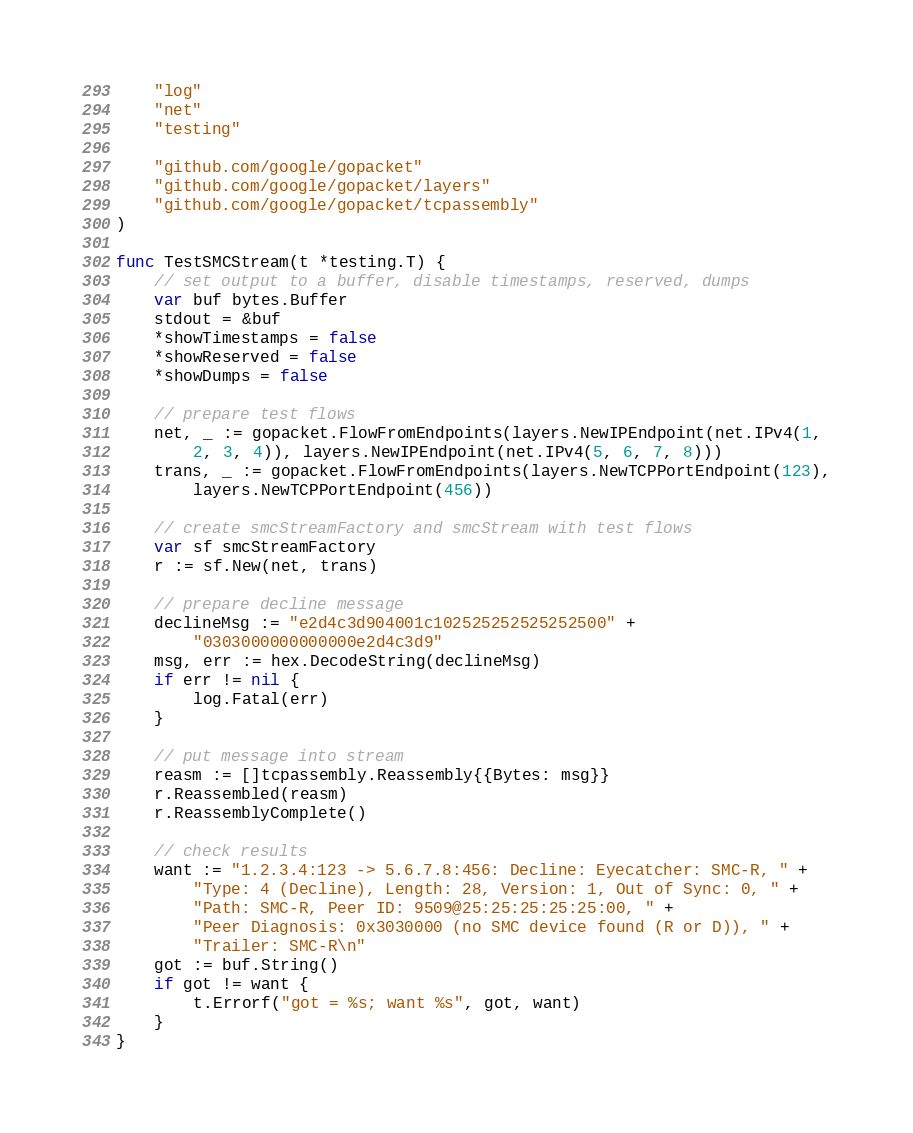<code> <loc_0><loc_0><loc_500><loc_500><_Go_>	"log"
	"net"
	"testing"

	"github.com/google/gopacket"
	"github.com/google/gopacket/layers"
	"github.com/google/gopacket/tcpassembly"
)

func TestSMCStream(t *testing.T) {
	// set output to a buffer, disable timestamps, reserved, dumps
	var buf bytes.Buffer
	stdout = &buf
	*showTimestamps = false
	*showReserved = false
	*showDumps = false

	// prepare test flows
	net, _ := gopacket.FlowFromEndpoints(layers.NewIPEndpoint(net.IPv4(1,
		2, 3, 4)), layers.NewIPEndpoint(net.IPv4(5, 6, 7, 8)))
	trans, _ := gopacket.FlowFromEndpoints(layers.NewTCPPortEndpoint(123),
		layers.NewTCPPortEndpoint(456))

	// create smcStreamFactory and smcStream with test flows
	var sf smcStreamFactory
	r := sf.New(net, trans)

	// prepare decline message
	declineMsg := "e2d4c3d904001c102525252525252500" +
		"0303000000000000e2d4c3d9"
	msg, err := hex.DecodeString(declineMsg)
	if err != nil {
		log.Fatal(err)
	}

	// put message into stream
	reasm := []tcpassembly.Reassembly{{Bytes: msg}}
	r.Reassembled(reasm)
	r.ReassemblyComplete()

	// check results
	want := "1.2.3.4:123 -> 5.6.7.8:456: Decline: Eyecatcher: SMC-R, " +
		"Type: 4 (Decline), Length: 28, Version: 1, Out of Sync: 0, " +
		"Path: SMC-R, Peer ID: 9509@25:25:25:25:25:00, " +
		"Peer Diagnosis: 0x3030000 (no SMC device found (R or D)), " +
		"Trailer: SMC-R\n"
	got := buf.String()
	if got != want {
		t.Errorf("got = %s; want %s", got, want)
	}
}
</code> 